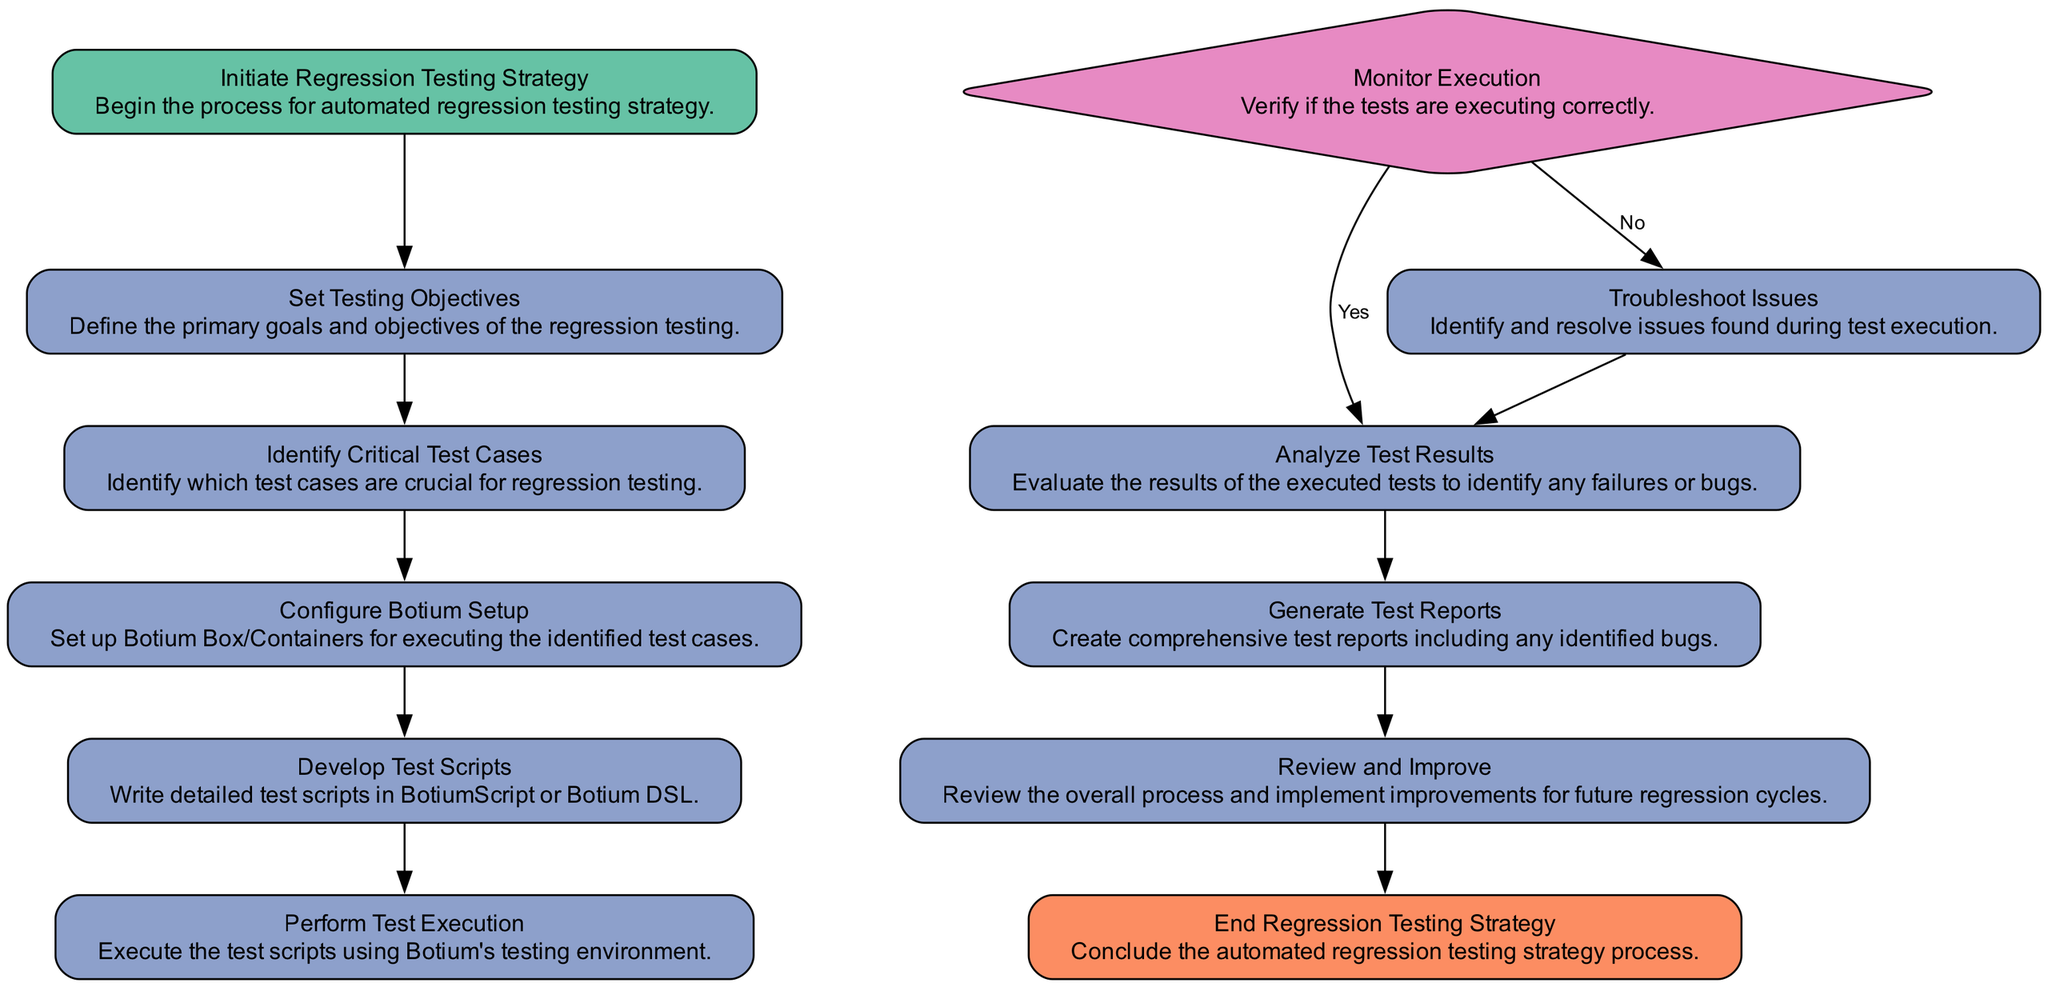What is the first step in the automated regression testing strategy? The flow chart indicates that the first step is to initiate the regression testing strategy, represented by the "Initiate Regression Testing Strategy" node.
Answer: Initiate Regression Testing Strategy How many process nodes are there in the diagram? By counting all the elements of type "process", we can find there are six process nodes: Set Testing Objectives, Identify Critical Test Cases, Configure Botium Setup, Develop Test Scripts, Perform Test Execution, Analyze Test Results, Generate Test Reports, and Review and Improve. The total number is eight.
Answer: Eight What follows after identifying critical test cases? The next step after the "Identify Critical Test Cases" node, as indicated by the flow, is to "Configure Botium Setup".
Answer: Configure Botium Setup What decision point is present in the execution phase? The diagram indicates a decision point labeled "Monitor Execution" which verifies if the tests are executing correctly.
Answer: Monitor Execution If test execution is successful, what is the next step? According to the flowchart, if the tests execute successfully, the next step is "Analyze Test Results".
Answer: Analyze Test Results What happens if there is an execution failure? If there is an execution failure as determined by the "Monitor Execution" decision node, the next step is to "Troubleshoot Issues".
Answer: Troubleshoot Issues How many branches are there from the decision node? The "Monitor Execution" decision node has two branches: one for "Execution Successful" and another for "Execution Failure". Therefore, there are two branches.
Answer: Two What is the final step in the regression testing strategy? The last step, marked as the end in the diagram, is "End Regression Testing Strategy."
Answer: End Regression Testing Strategy What is generated after analyzing test results? Following the "Analyze Test Results" node in the flow, the next process is to "Generate Test Reports".
Answer: Generate Test Reports 